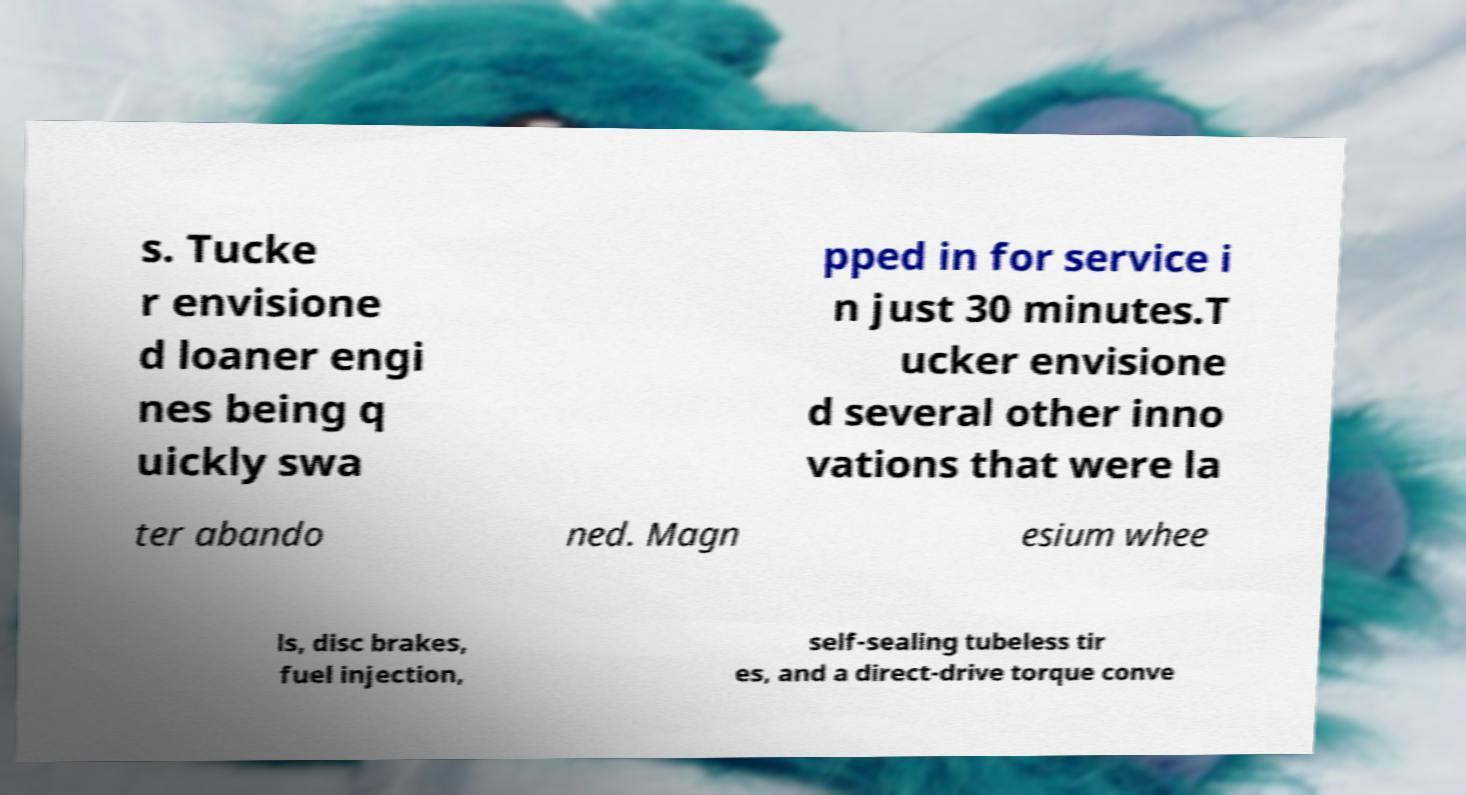Can you accurately transcribe the text from the provided image for me? s. Tucke r envisione d loaner engi nes being q uickly swa pped in for service i n just 30 minutes.T ucker envisione d several other inno vations that were la ter abando ned. Magn esium whee ls, disc brakes, fuel injection, self-sealing tubeless tir es, and a direct-drive torque conve 